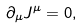Convert formula to latex. <formula><loc_0><loc_0><loc_500><loc_500>\partial _ { \mu } J ^ { \mu } = 0 ,</formula> 